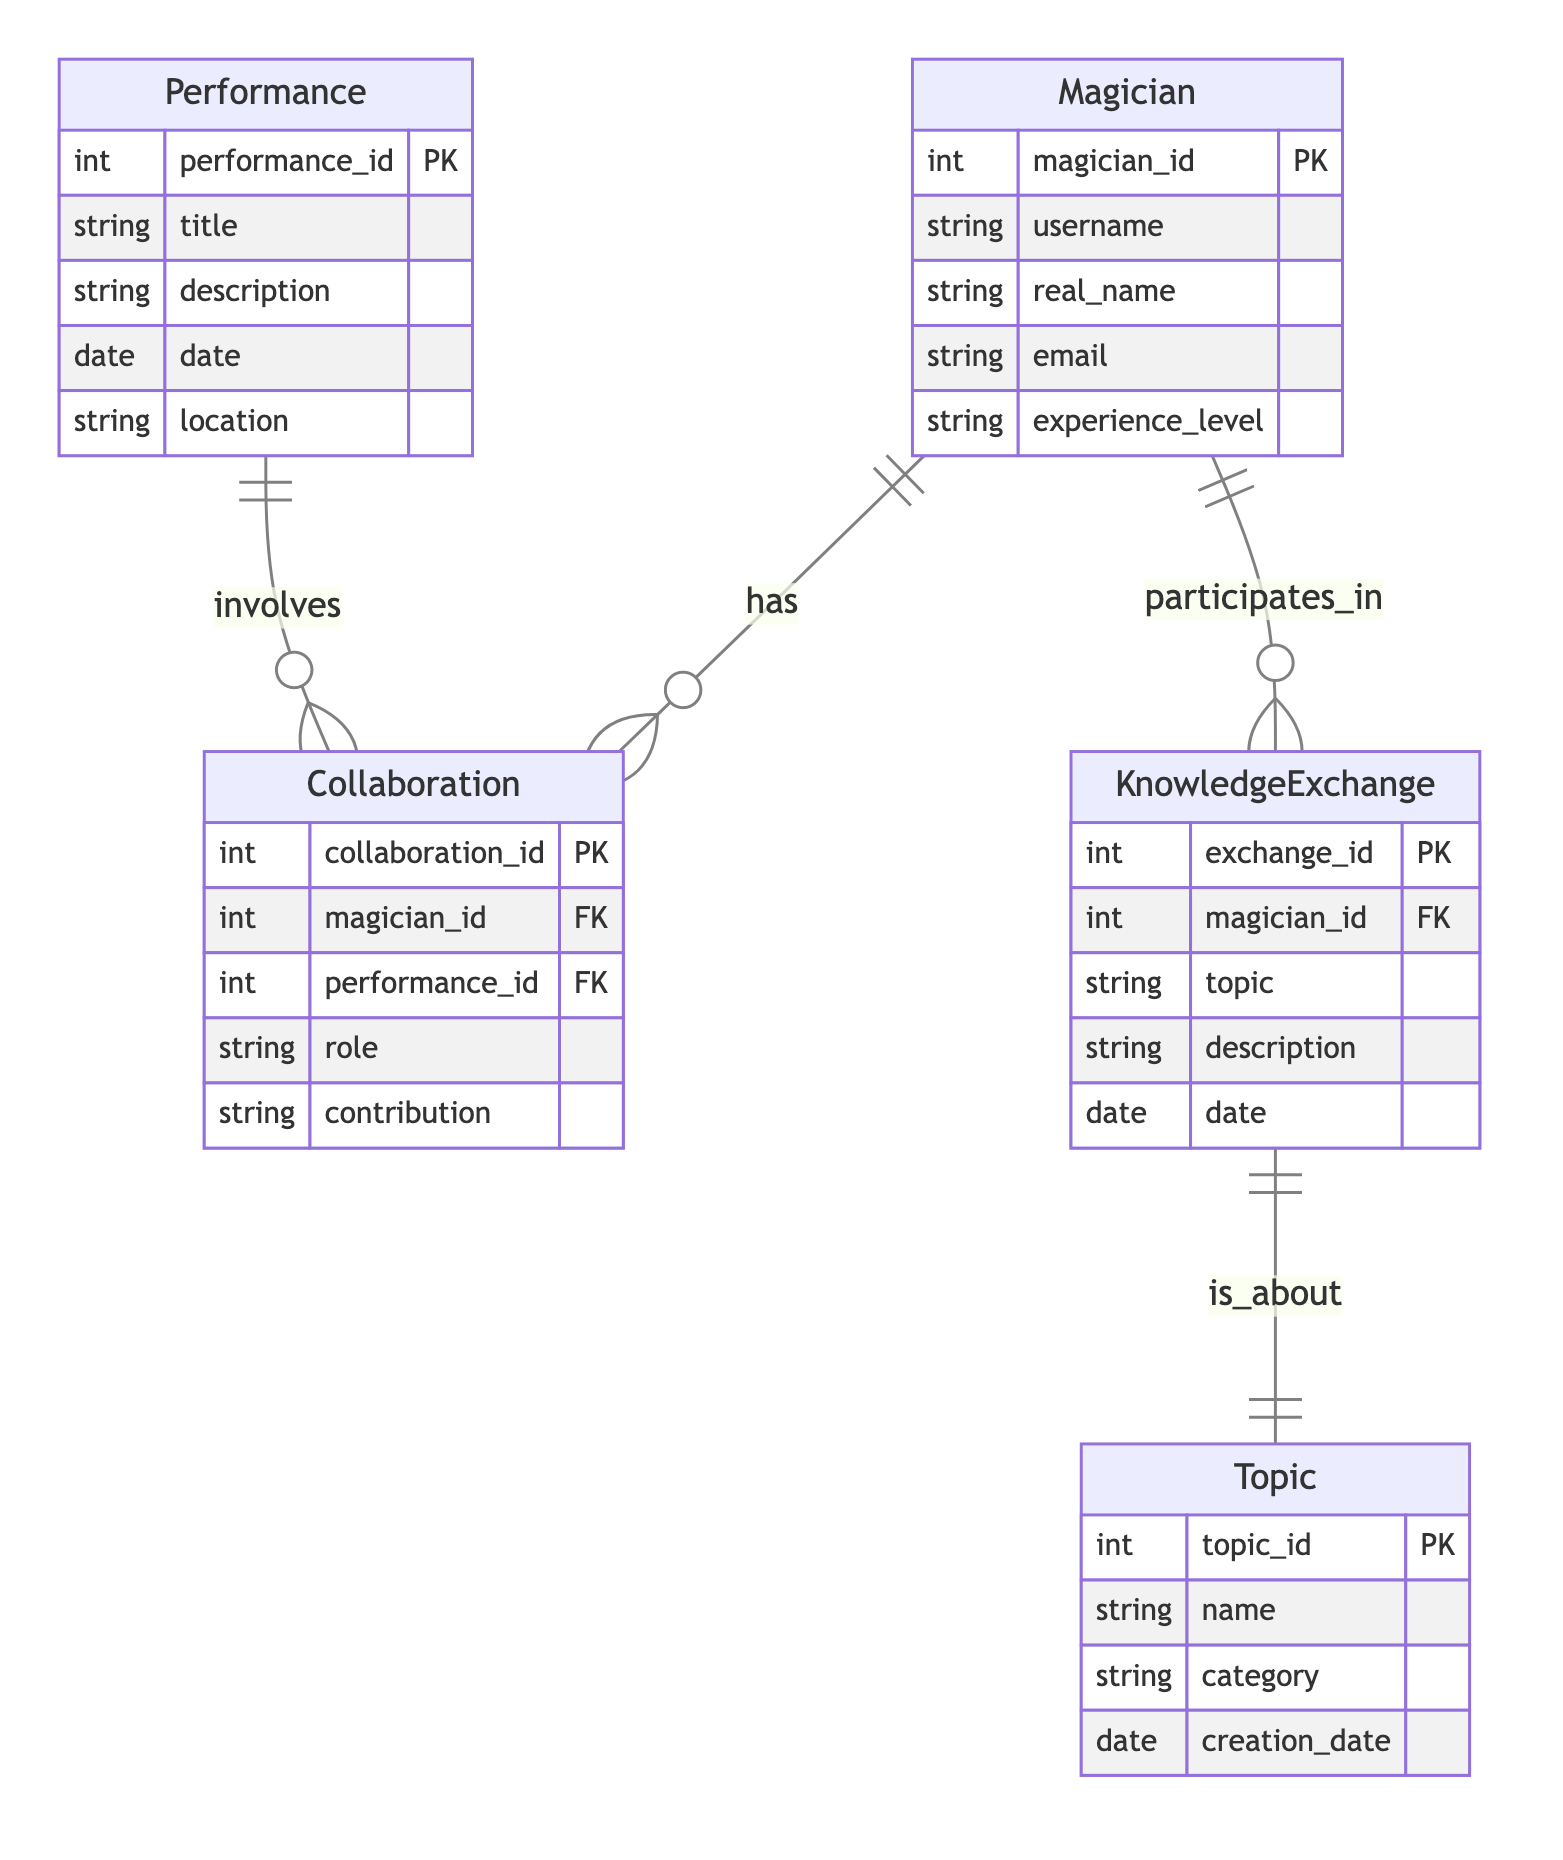What is the primary entity that represents a magician in the diagram? The diagram clearly identifies "Magician" as an entity, which is the main representation of individual magicians within the system.
Answer: Magician How many attributes does the "KnowledgeExchange" entity have? By reviewing the "KnowledgeExchange" entity in the diagram, we see it has five attributes: exchange_id, magician_id, topic, description, and date.
Answer: Five What relationship exists between "Magician" and "Collaboration"? The diagram shows that the relationship type between "Magician" and "Collaboration" is "has," indicating that a magician can participate in multiple collaborations.
Answer: has Which entity is directly related to the "Performance" entity? The "Collaboration" entity is directly related to "Performance," as indicated by the relationship that states a performance can involve multiple collaborations.
Answer: Collaboration How many entities are involved in the knowledge exchange process? The diagram shows two entities involved in the knowledge exchange process: "Magician" and "KnowledgeExchange."
Answer: Two What is the role of the "Topic" entity in relation to "KnowledgeExchange"? The relationship between "KnowledgeExchange" and "Topic" indicates that a knowledge exchange session is about a single topic, making "Topic" vital for detailing the subject matter discussed.
Answer: is about Which entity can a magician not directly contribute to? A magician does not directly contribute to the "Topic" entity, as it is not listed in the relationships stemming from "Magician" in the diagram.
Answer: Topic How many collaborations can a single magician participate in? The diagram indicates that a single magician can participate in multiple collaborations, pointing to a one-to-many relationship.
Answer: Multiple What attribute is unique to the "Performance" entity? The "performance_id" is a primary key attribute of the "Performance" entity, making it unique as it identifies each performance distinctly.
Answer: performance_id 